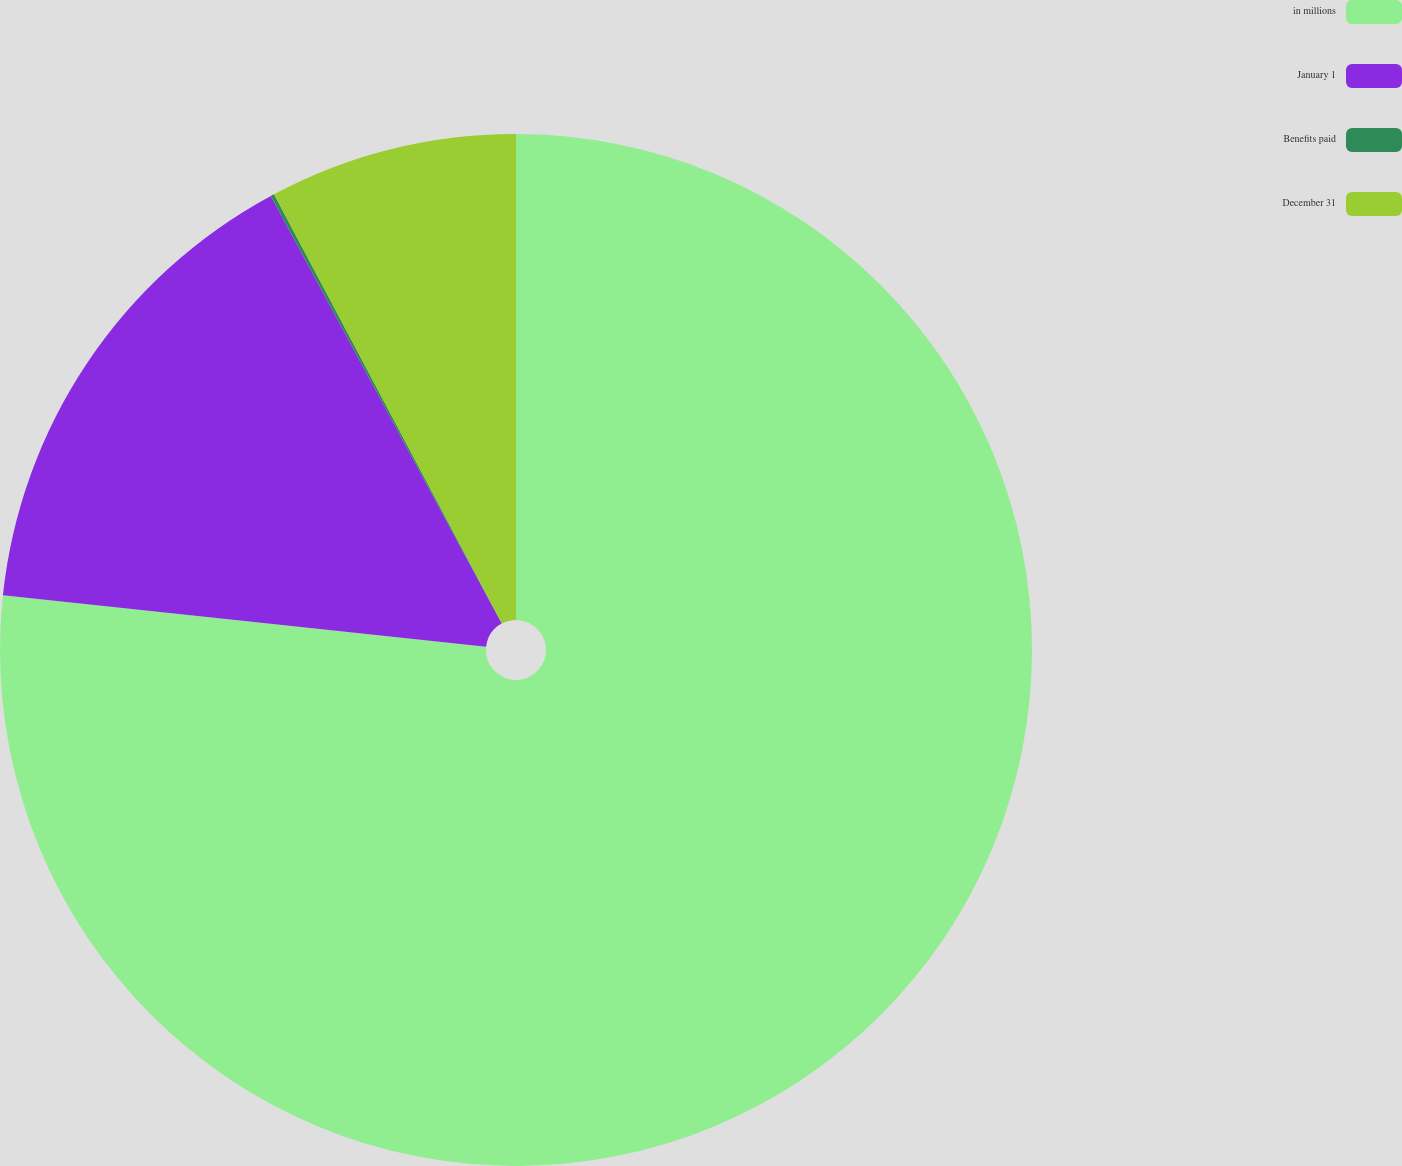Convert chart. <chart><loc_0><loc_0><loc_500><loc_500><pie_chart><fcel>in millions<fcel>January 1<fcel>Benefits paid<fcel>December 31<nl><fcel>76.69%<fcel>15.43%<fcel>0.11%<fcel>7.77%<nl></chart> 